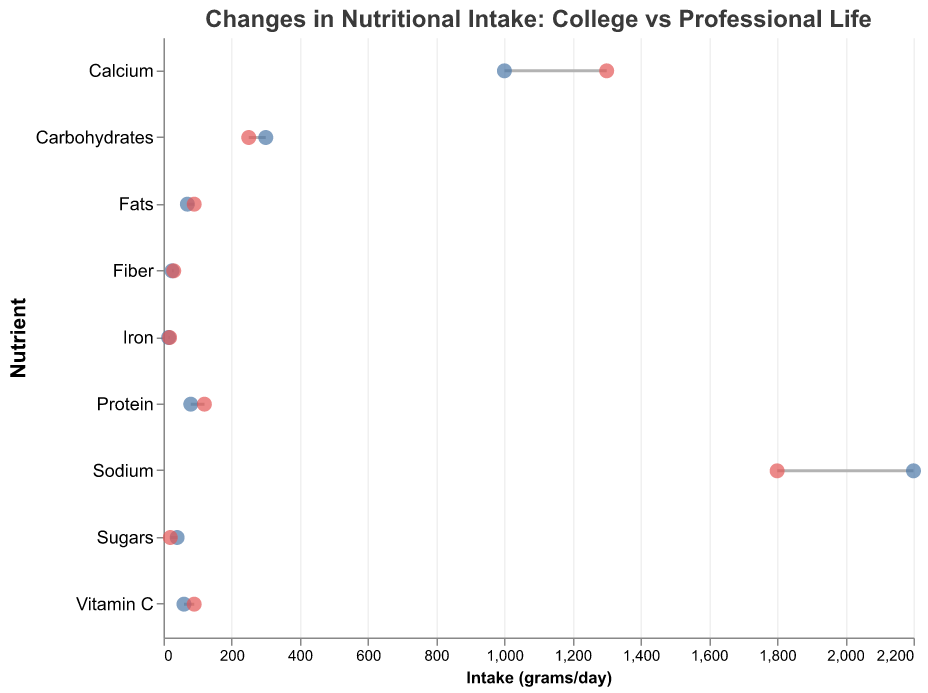What is the title of the figure? The title can be found at the top of the figure in a larger font size.
Answer: Changes in Nutritional Intake: College vs Professional Life How many nutrients are compared in this figure? Count the unique nutrients listed along the y-axis.
Answer: 9 Which nutrient has the biggest increase in intake from college to professional life? Look for the nutrient with the longest line where the professional intake is significantly higher than the college intake. Compare all lines visually.
Answer: Protein Which nutrient has the most significant decrease in intake from college to professional life? Find the nutrient with the longest line where the college intake is higher than the professional intake. Compare all lines visually.
Answer: Sugars What is the difference in calcium intake between college and professional life? Find the positions for calcium on the x-axis and calculate the absolute difference between professional and college values.
Answer: 300 grams/day What are the intake values for sodium in college and professional life? Locate the points for sodium along the x-axis and note down the values for both college and professional life.
Answer: 2200 grams/day (college), 1800 grams/day (professional) For which nutrients do professional fitness enthusiasts have a higher intake compared to their college years? Identify nutrients where the point for professional intake is further to the right on the x-axis compared to college intake.
Answer: Protein, Fats, Fiber, Calcium, Iron, Vitamin C Is fiber intake higher in college or professional life? Compare the x-axis positions of the fiber intake values for college and professional life.
Answer: Professional life What is the combined intake of sodium and the sum of calcium during professional life? Locate the values for both nutrients for professional life and sum them up.
Answer: 1800 + 1300 = 3100 grams/day Which nutrient has the smallest change in intake between college and professional life? Identify the nutrient with the shortest line between college and professional data points.
Answer: Fiber 